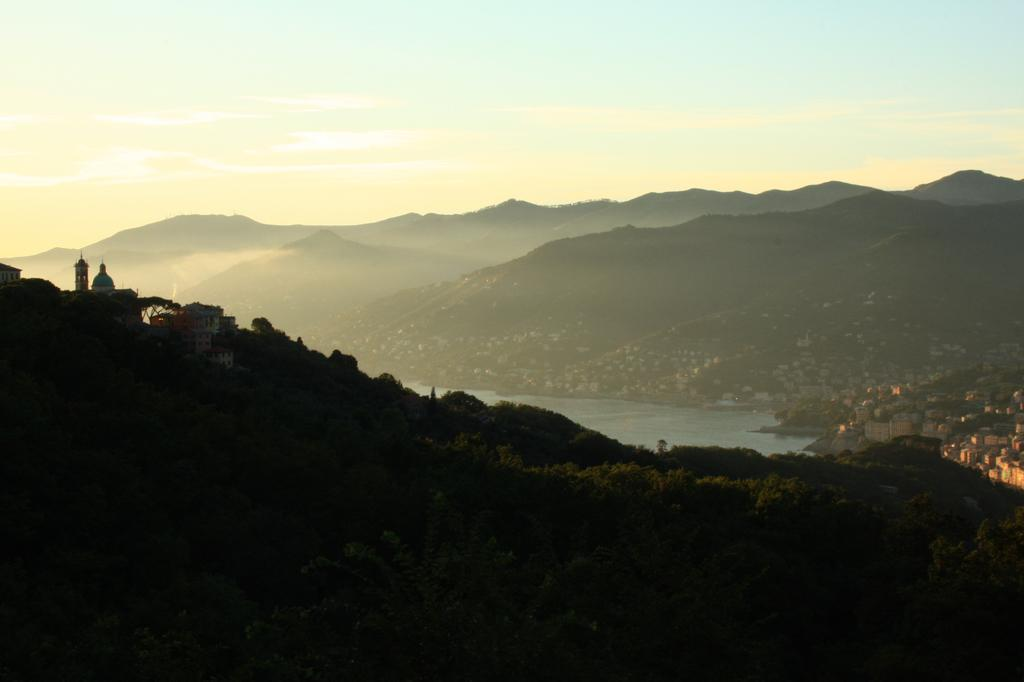What type of natural feature can be seen in the image? There are mountains in the image. What body of water is present in the image? There is a lake in the middle of the image. Are there any man-made structures near the lake? Yes, there are buildings beside the lake. What type of flower can be seen growing near the lake in the image? There is no flower present in the image; it features mountains, a lake, and buildings. 